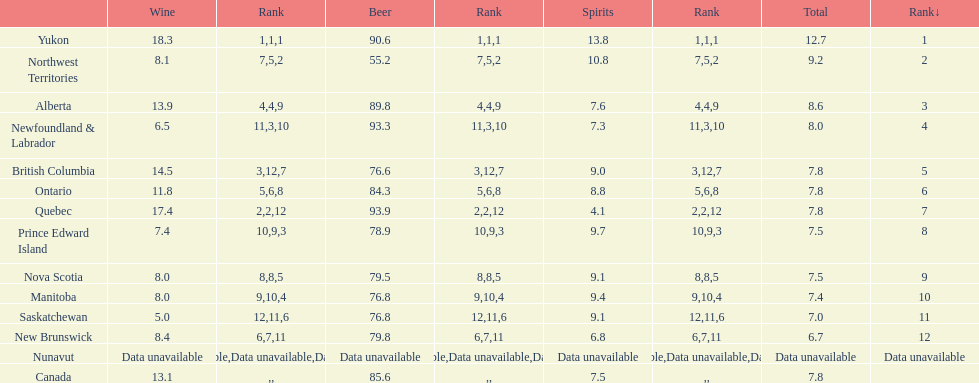What are the number of territories that have a wine consumption above 10.0? 5. 